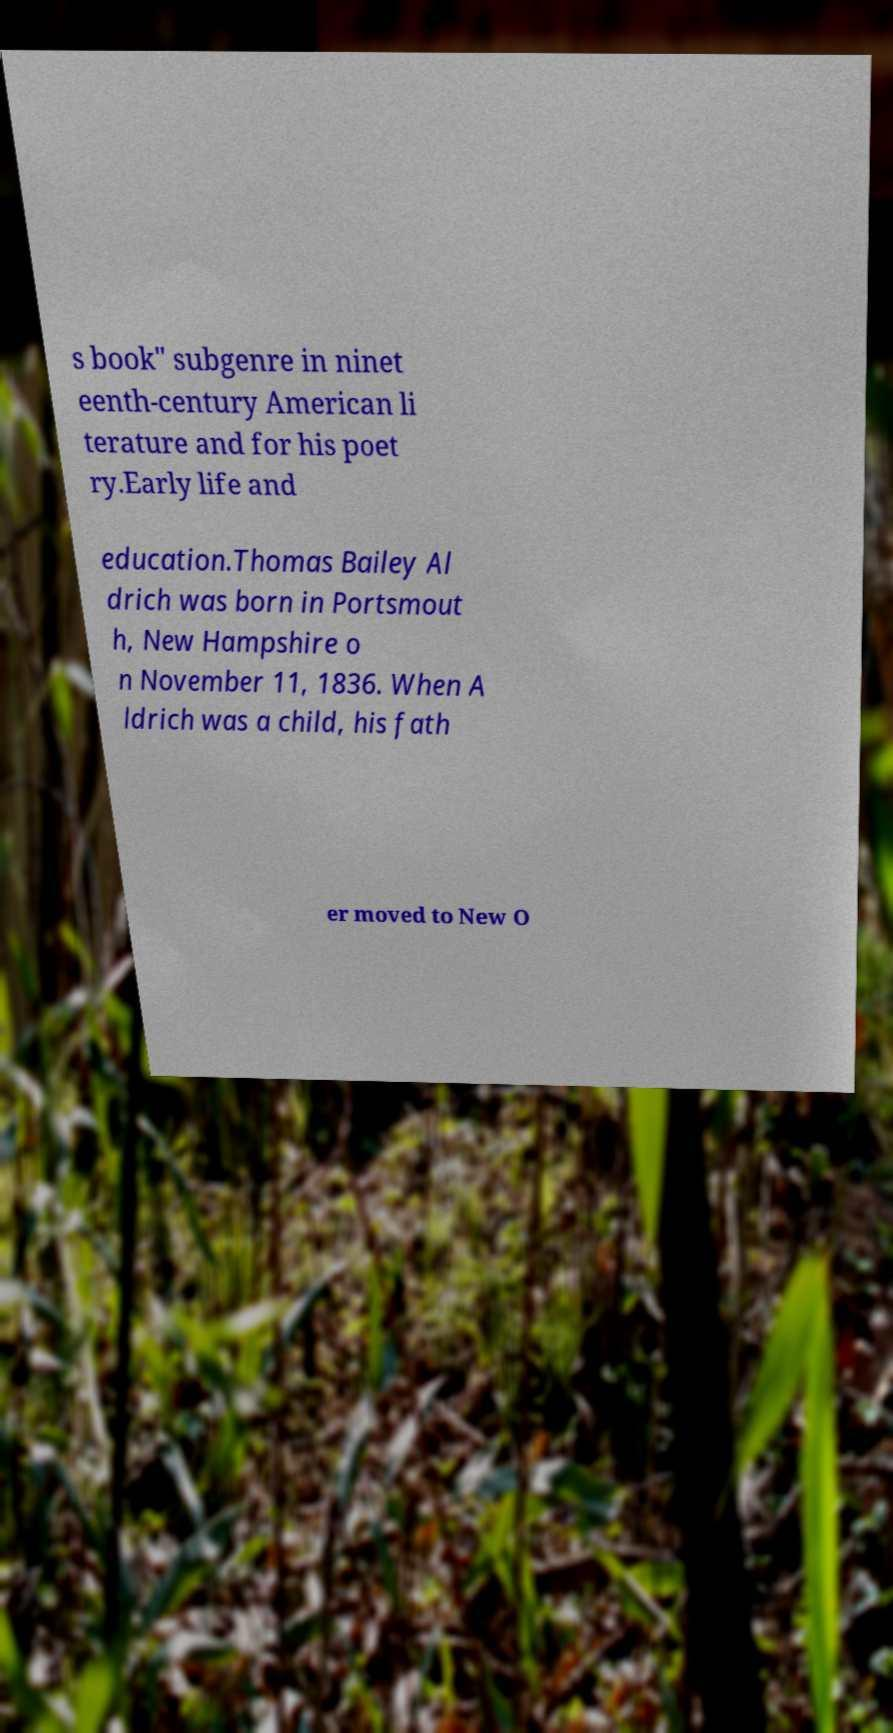Please read and relay the text visible in this image. What does it say? s book" subgenre in ninet eenth-century American li terature and for his poet ry.Early life and education.Thomas Bailey Al drich was born in Portsmout h, New Hampshire o n November 11, 1836. When A ldrich was a child, his fath er moved to New O 